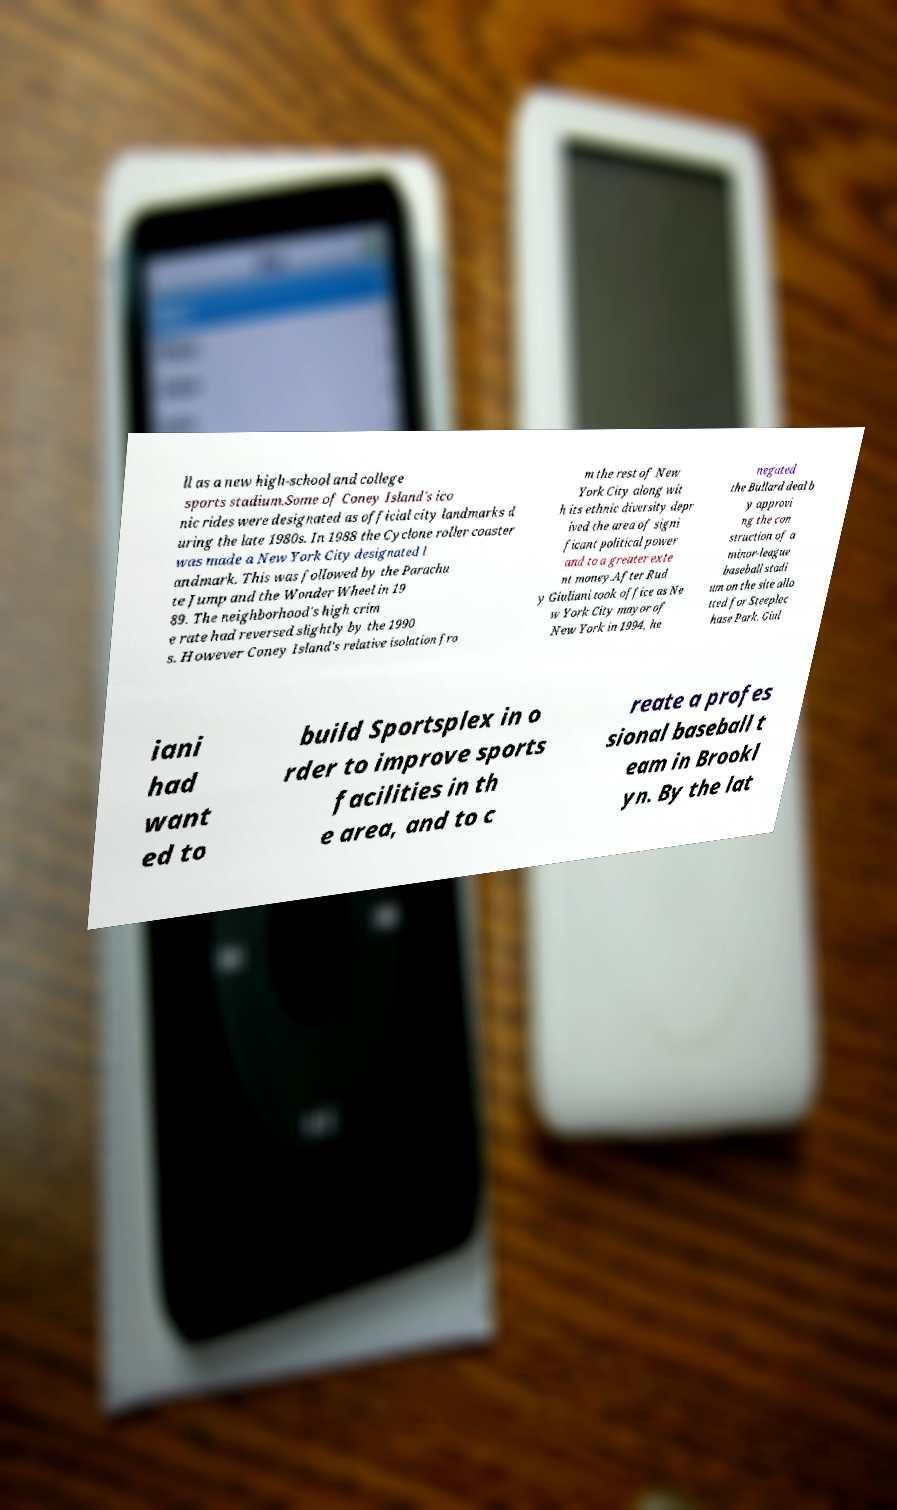There's text embedded in this image that I need extracted. Can you transcribe it verbatim? ll as a new high-school and college sports stadium.Some of Coney Island's ico nic rides were designated as official city landmarks d uring the late 1980s. In 1988 the Cyclone roller coaster was made a New York City designated l andmark. This was followed by the Parachu te Jump and the Wonder Wheel in 19 89. The neighborhood's high crim e rate had reversed slightly by the 1990 s. However Coney Island's relative isolation fro m the rest of New York City along wit h its ethnic diversity depr ived the area of signi ficant political power and to a greater exte nt money.After Rud y Giuliani took office as Ne w York City mayor of New York in 1994, he negated the Bullard deal b y approvi ng the con struction of a minor-league baseball stadi um on the site allo tted for Steeplec hase Park. Giul iani had want ed to build Sportsplex in o rder to improve sports facilities in th e area, and to c reate a profes sional baseball t eam in Brookl yn. By the lat 